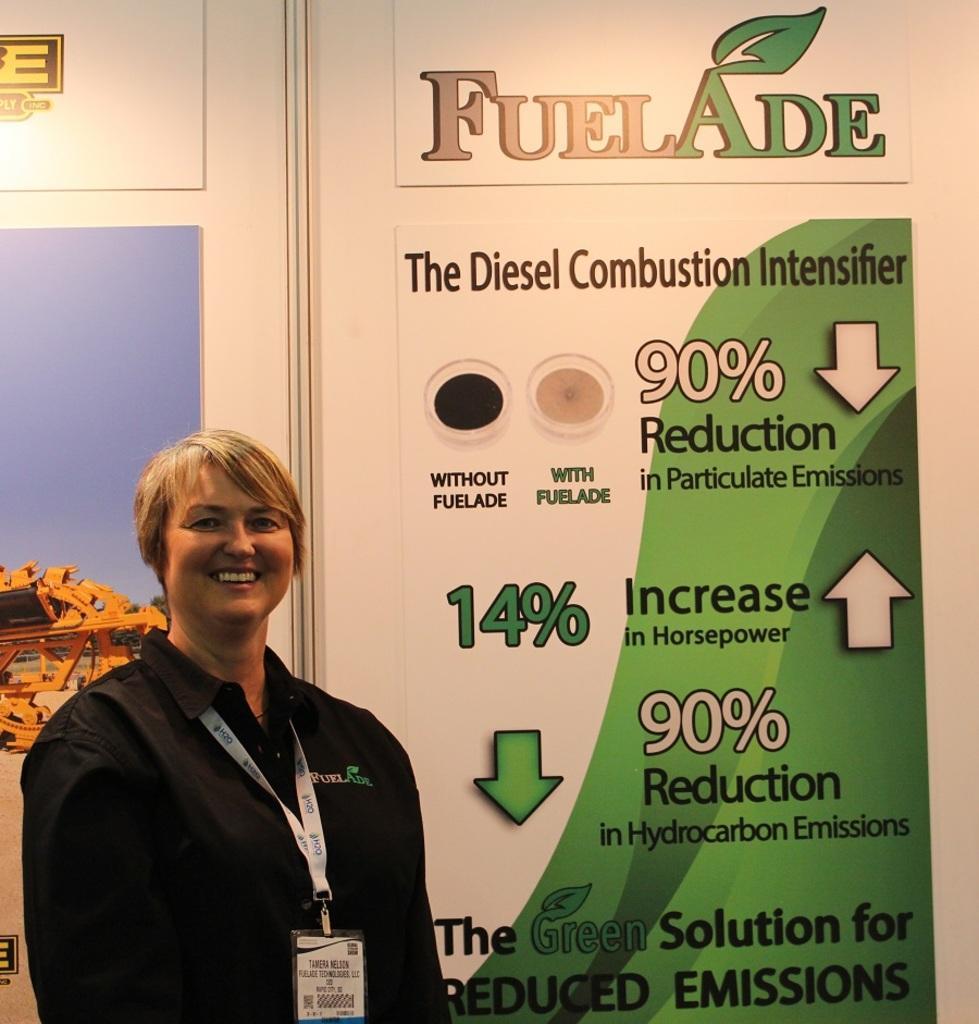How would you summarize this image in a sentence or two? In this image we can see a woman standing and smiling. In the background there is an advertisement. 